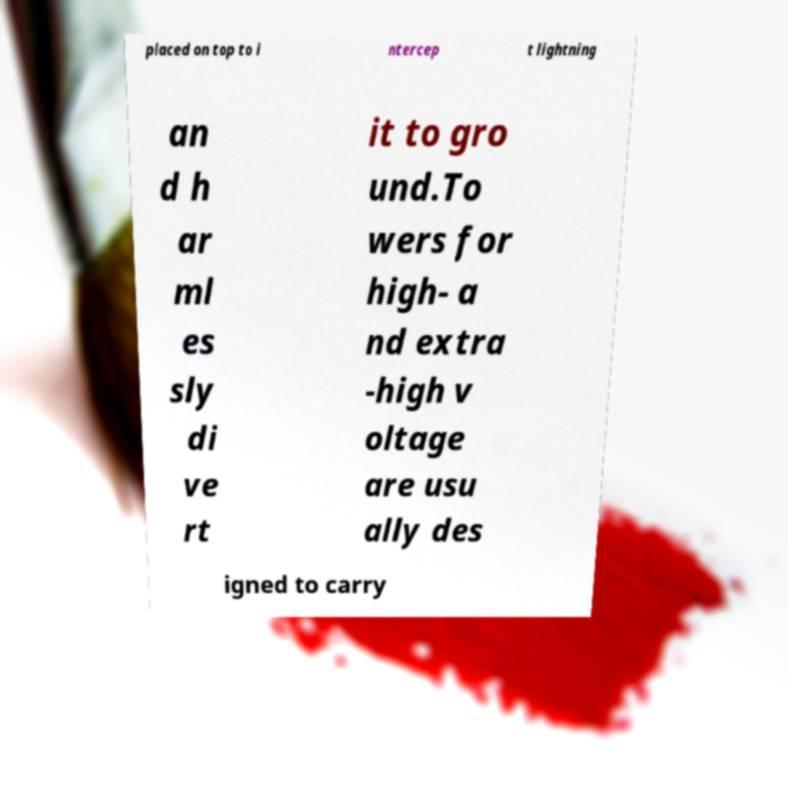For documentation purposes, I need the text within this image transcribed. Could you provide that? placed on top to i ntercep t lightning an d h ar ml es sly di ve rt it to gro und.To wers for high- a nd extra -high v oltage are usu ally des igned to carry 